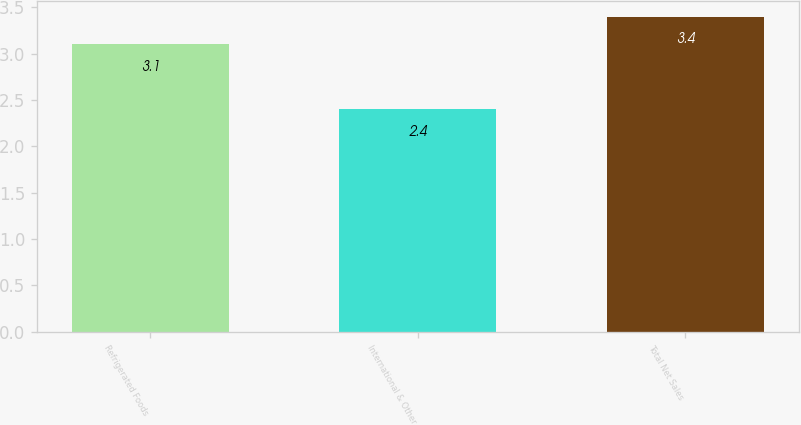Convert chart. <chart><loc_0><loc_0><loc_500><loc_500><bar_chart><fcel>Refrigerated Foods<fcel>International & Other<fcel>Total Net Sales<nl><fcel>3.1<fcel>2.4<fcel>3.4<nl></chart> 